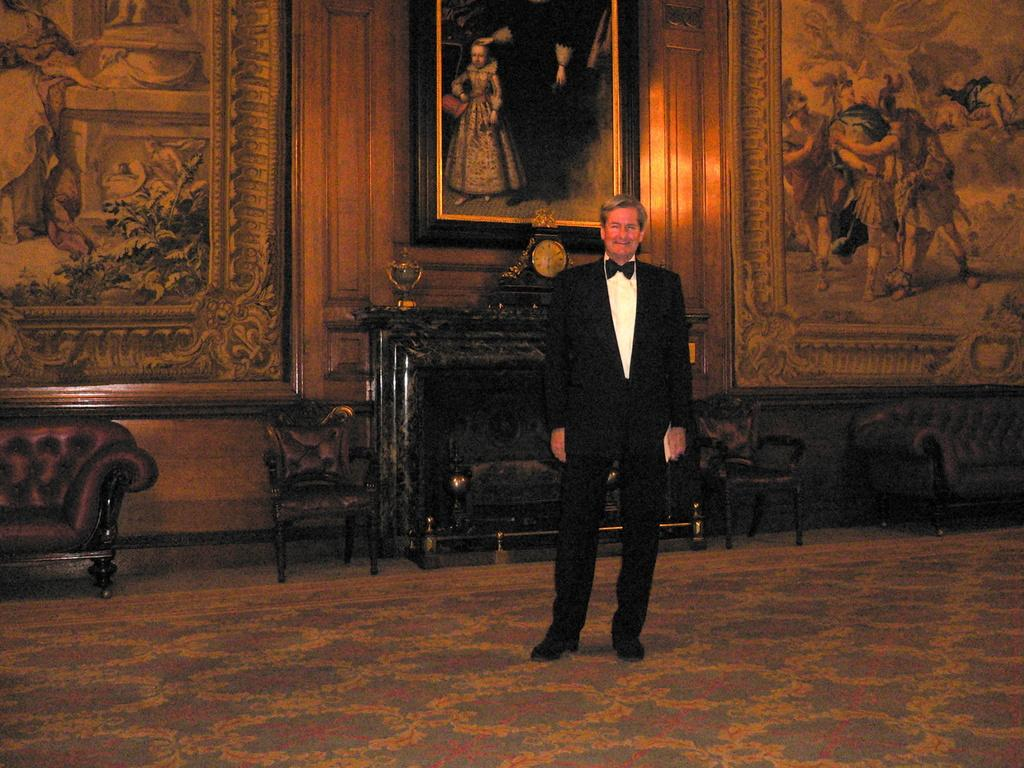Who is present in the image? There is a man in the image. What is the man wearing? The man is wearing a black blazer. Where is the man standing? The man is standing on the floor. What can be seen in the background of the image? There is a wall in the background of the image. What is on the wall in the image? The wall has paintings and photo frames on it. Where is the minister sitting in the image? There is no minister present in the image, and no one is sitting. What type of field can be seen in the image? There is no field present in the image; it features a man standing in front of a wall with paintings and photo frames. 